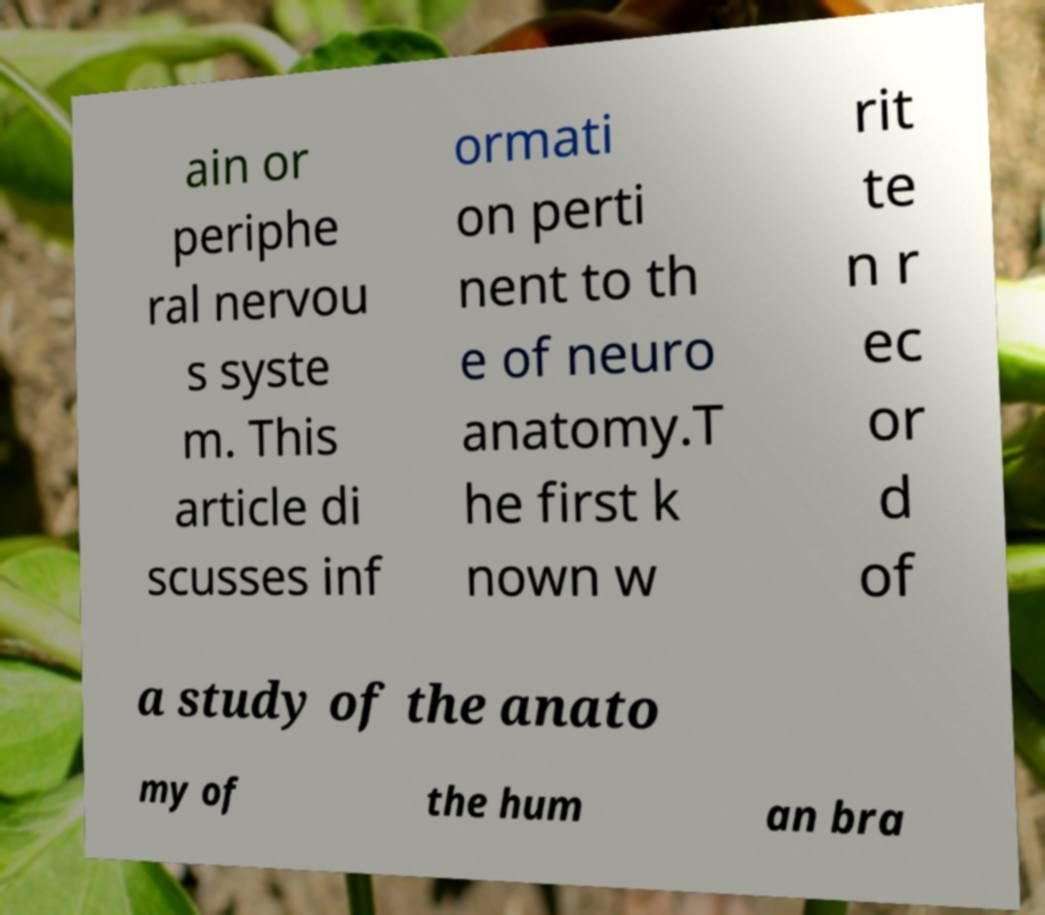There's text embedded in this image that I need extracted. Can you transcribe it verbatim? ain or periphe ral nervou s syste m. This article di scusses inf ormati on perti nent to th e of neuro anatomy.T he first k nown w rit te n r ec or d of a study of the anato my of the hum an bra 